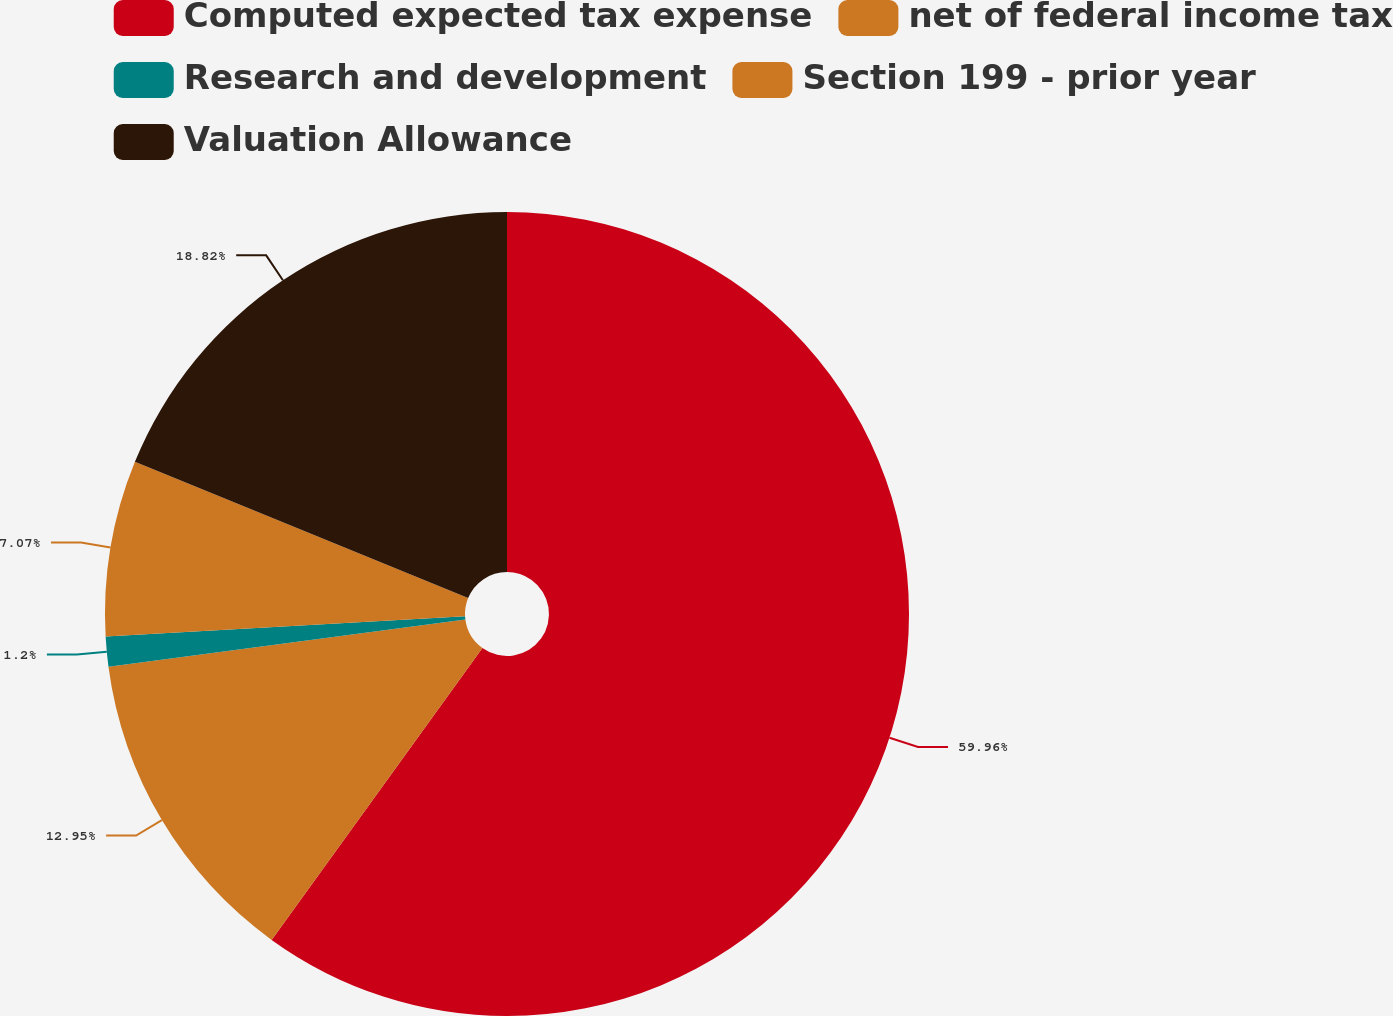<chart> <loc_0><loc_0><loc_500><loc_500><pie_chart><fcel>Computed expected tax expense<fcel>net of federal income tax<fcel>Research and development<fcel>Section 199 - prior year<fcel>Valuation Allowance<nl><fcel>59.95%<fcel>12.95%<fcel>1.2%<fcel>7.07%<fcel>18.82%<nl></chart> 